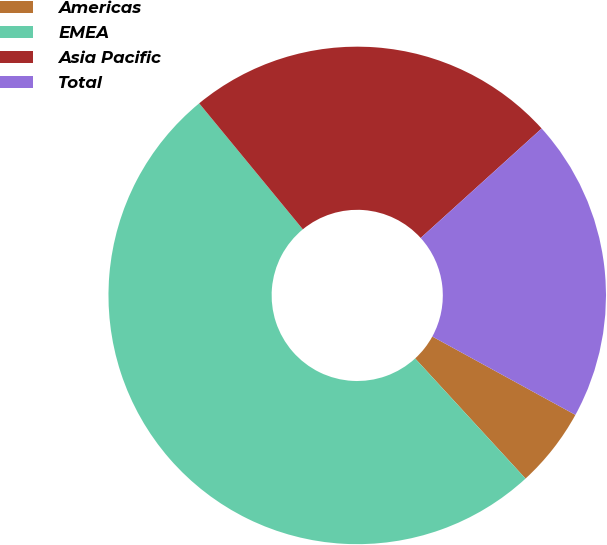Convert chart to OTSL. <chart><loc_0><loc_0><loc_500><loc_500><pie_chart><fcel>Americas<fcel>EMEA<fcel>Asia Pacific<fcel>Total<nl><fcel>5.2%<fcel>50.87%<fcel>24.25%<fcel>19.68%<nl></chart> 